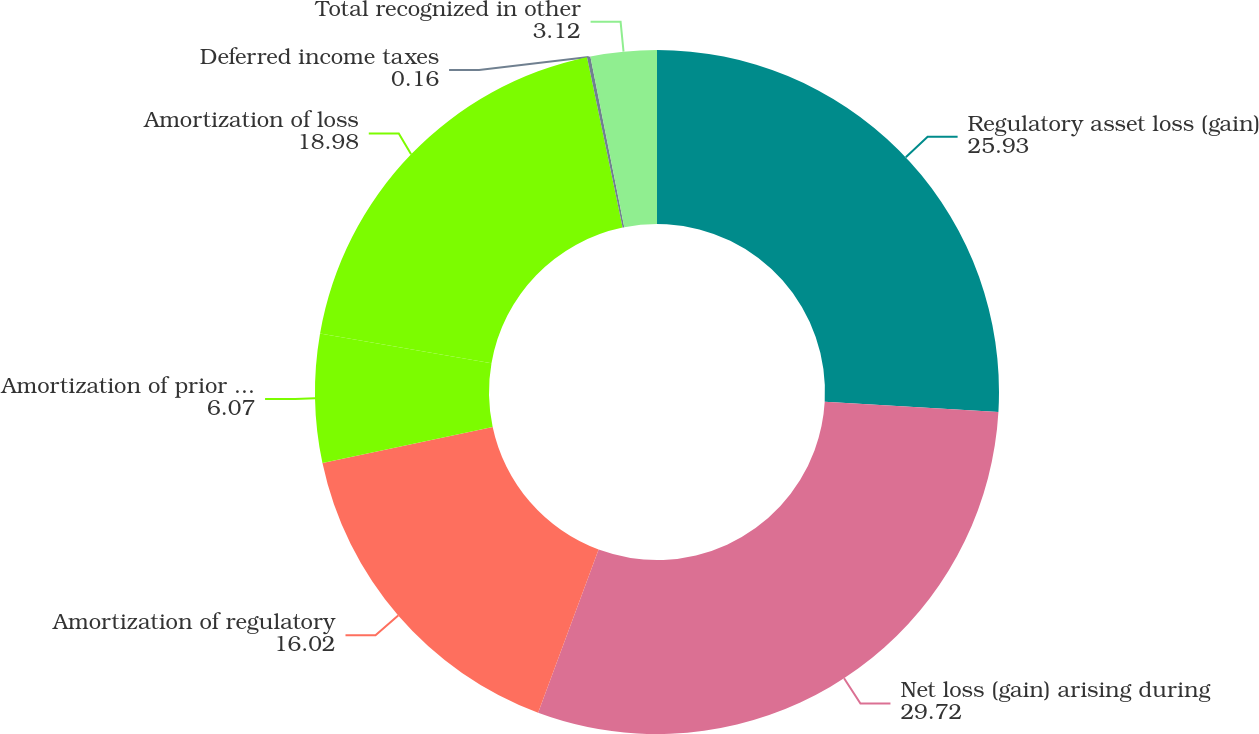Convert chart to OTSL. <chart><loc_0><loc_0><loc_500><loc_500><pie_chart><fcel>Regulatory asset loss (gain)<fcel>Net loss (gain) arising during<fcel>Amortization of regulatory<fcel>Amortization of prior service<fcel>Amortization of loss<fcel>Deferred income taxes<fcel>Total recognized in other<nl><fcel>25.93%<fcel>29.72%<fcel>16.02%<fcel>6.07%<fcel>18.98%<fcel>0.16%<fcel>3.12%<nl></chart> 